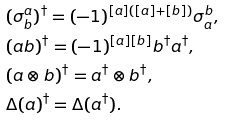<formula> <loc_0><loc_0><loc_500><loc_500>& ( \sigma ^ { a } _ { b } ) ^ { \dagger } = ( - 1 ) ^ { [ a ] ( [ a ] + [ b ] ) } \sigma ^ { b } _ { a } , \\ & ( a b ) ^ { \dagger } = ( - 1 ) ^ { [ a ] [ b ] } b ^ { \dagger } a ^ { \dagger } , \\ & ( a \otimes b ) ^ { \dagger } = a ^ { \dagger } \otimes b ^ { \dagger } , \\ & \Delta ( a ) ^ { \dagger } = \Delta ( a ^ { \dagger } ) .</formula> 